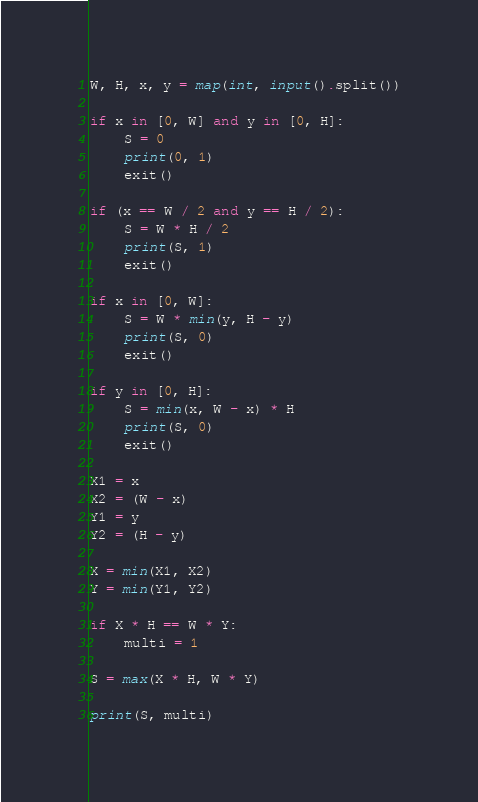<code> <loc_0><loc_0><loc_500><loc_500><_Python_>W, H, x, y = map(int, input().split())

if x in [0, W] and y in [0, H]:
    S = 0
    print(0, 1)
    exit()

if (x == W / 2 and y == H / 2):
    S = W * H / 2
    print(S, 1)
    exit()

if x in [0, W]:
    S = W * min(y, H - y)
    print(S, 0)
    exit()

if y in [0, H]:
    S = min(x, W - x) * H
    print(S, 0)
    exit()

X1 = x
X2 = (W - x)
Y1 = y
Y2 = (H - y)

X = min(X1, X2)
Y = min(Y1, Y2)

if X * H == W * Y:
    multi = 1

S = max(X * H, W * Y)

print(S, multi)
</code> 